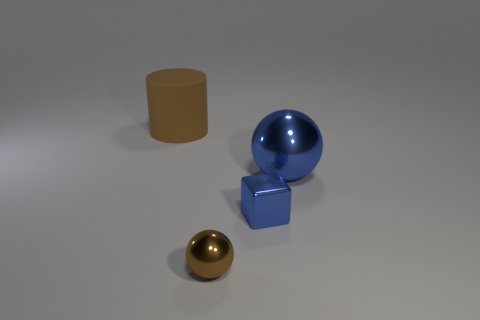Is the number of blue spheres that are behind the big brown object greater than the number of big things that are in front of the large blue sphere?
Your answer should be compact. No. Is the number of large brown objects greater than the number of big gray matte blocks?
Offer a terse response. Yes. There is a metal thing that is both on the left side of the big blue sphere and right of the brown ball; what size is it?
Keep it short and to the point. Small. What is the shape of the tiny blue metal object?
Your answer should be compact. Cube. Are there more tiny shiny blocks that are behind the cube than blue shiny blocks?
Your answer should be compact. No. What shape is the small thing behind the ball in front of the big object right of the big cylinder?
Your response must be concise. Cube. Do the brown thing in front of the brown cylinder and the tiny blue object have the same size?
Offer a terse response. Yes. There is a object that is behind the tiny ball and on the left side of the blue block; what is its shape?
Offer a very short reply. Cylinder. Do the tiny ball and the thing that is right of the tiny blue metallic thing have the same color?
Provide a short and direct response. No. There is a metallic ball that is behind the brown sphere that is in front of the large thing that is in front of the big matte thing; what color is it?
Make the answer very short. Blue. 